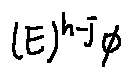Convert formula to latex. <formula><loc_0><loc_0><loc_500><loc_500>( E ) ^ { h - j } \phi</formula> 